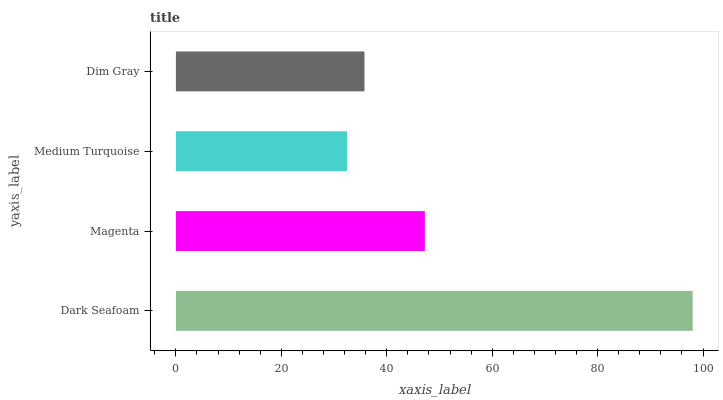Is Medium Turquoise the minimum?
Answer yes or no. Yes. Is Dark Seafoam the maximum?
Answer yes or no. Yes. Is Magenta the minimum?
Answer yes or no. No. Is Magenta the maximum?
Answer yes or no. No. Is Dark Seafoam greater than Magenta?
Answer yes or no. Yes. Is Magenta less than Dark Seafoam?
Answer yes or no. Yes. Is Magenta greater than Dark Seafoam?
Answer yes or no. No. Is Dark Seafoam less than Magenta?
Answer yes or no. No. Is Magenta the high median?
Answer yes or no. Yes. Is Dim Gray the low median?
Answer yes or no. Yes. Is Dark Seafoam the high median?
Answer yes or no. No. Is Magenta the low median?
Answer yes or no. No. 